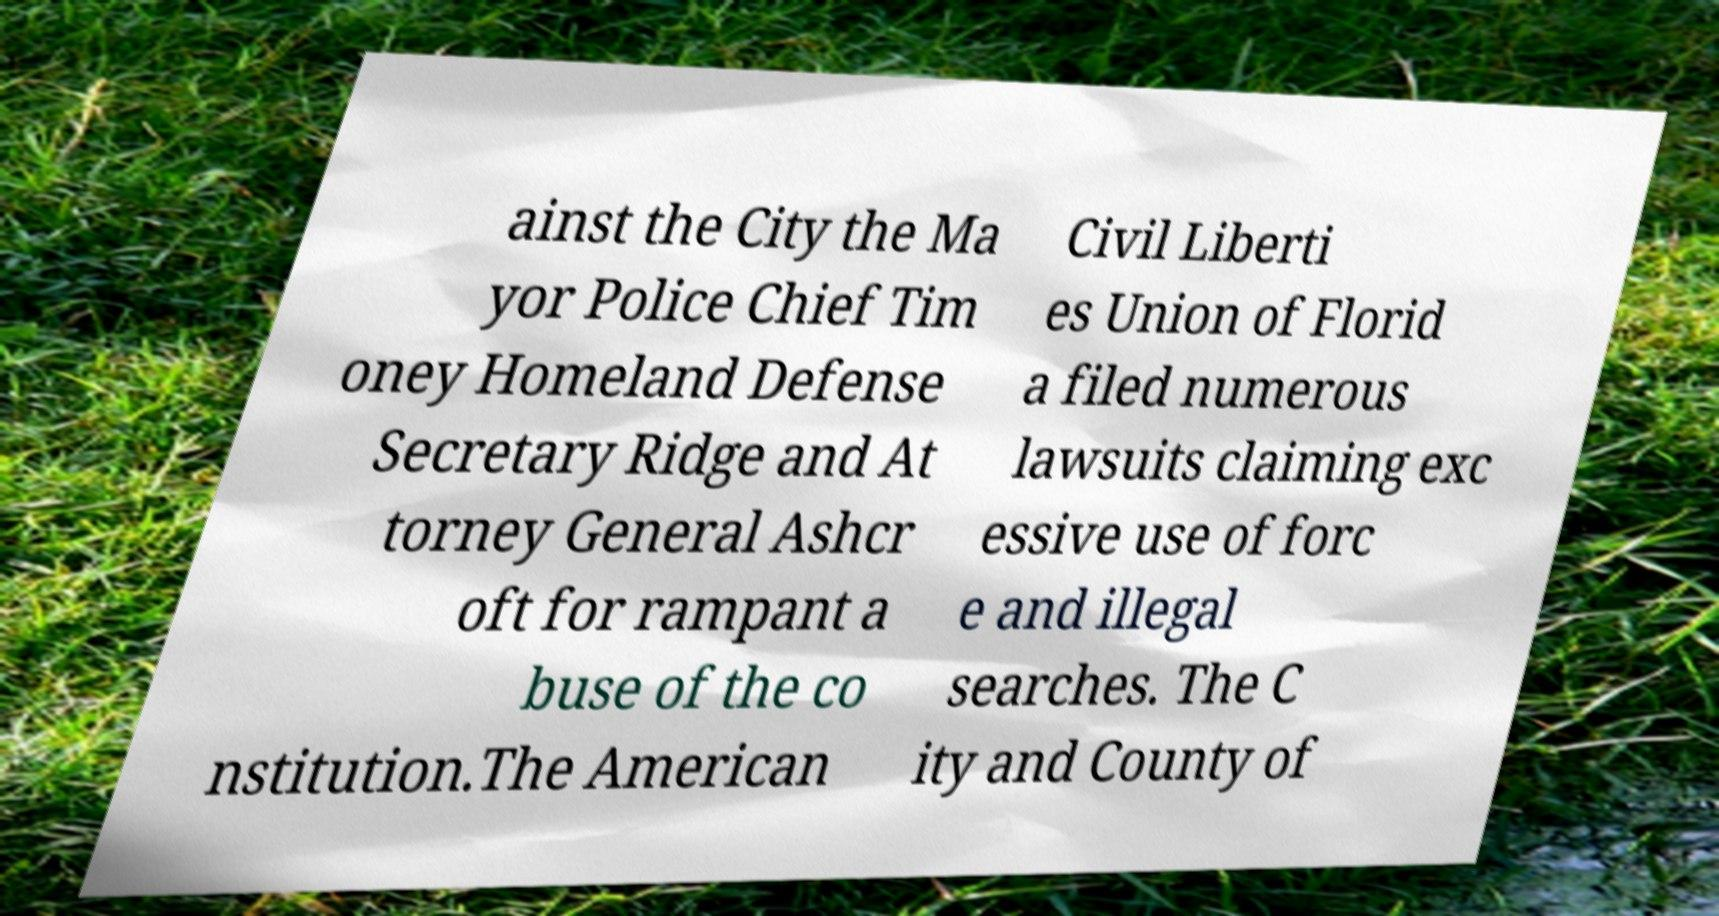There's text embedded in this image that I need extracted. Can you transcribe it verbatim? ainst the City the Ma yor Police Chief Tim oney Homeland Defense Secretary Ridge and At torney General Ashcr oft for rampant a buse of the co nstitution.The American Civil Liberti es Union of Florid a filed numerous lawsuits claiming exc essive use of forc e and illegal searches. The C ity and County of 